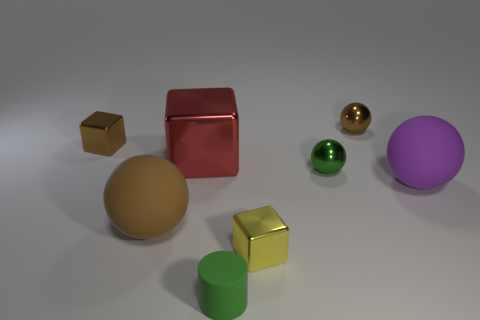Subtract all purple rubber balls. How many balls are left? 3 Add 1 green things. How many objects exist? 9 Subtract all yellow blocks. How many blocks are left? 2 Subtract all cubes. How many objects are left? 5 Subtract all yellow balls. How many yellow cubes are left? 1 Add 4 yellow cubes. How many yellow cubes are left? 5 Add 7 small blocks. How many small blocks exist? 9 Subtract 0 blue cubes. How many objects are left? 8 Subtract all gray blocks. Subtract all gray cylinders. How many blocks are left? 3 Subtract all large matte blocks. Subtract all purple matte objects. How many objects are left? 7 